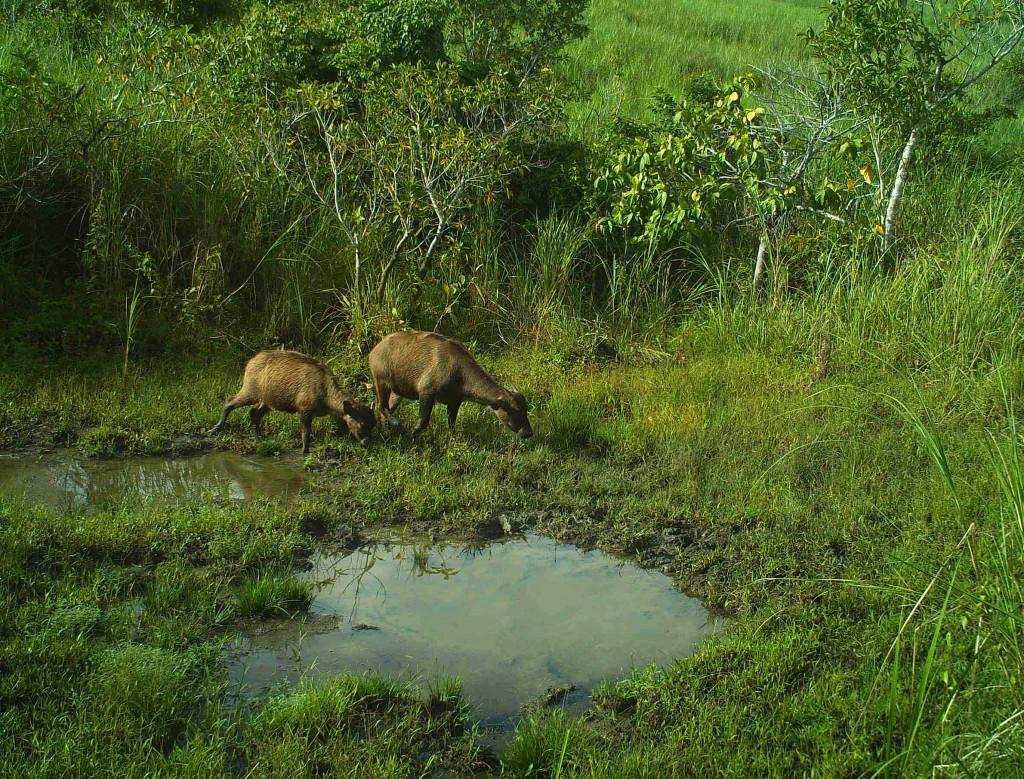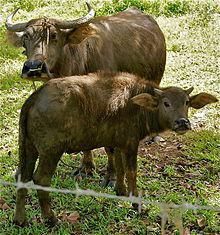The first image is the image on the left, the second image is the image on the right. Assess this claim about the two images: "Each image contains exactly one dark water buffalo, and no images contain humans.". Correct or not? Answer yes or no. No. The first image is the image on the left, the second image is the image on the right. Assess this claim about the two images: "Two animals are near a small body of water.". Correct or not? Answer yes or no. Yes. 